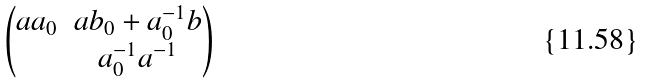<formula> <loc_0><loc_0><loc_500><loc_500>\begin{pmatrix} a a _ { 0 } & a b _ { 0 } + a _ { 0 } ^ { - 1 } b \\ & a _ { 0 } ^ { - 1 } a ^ { - 1 } \end{pmatrix}</formula> 